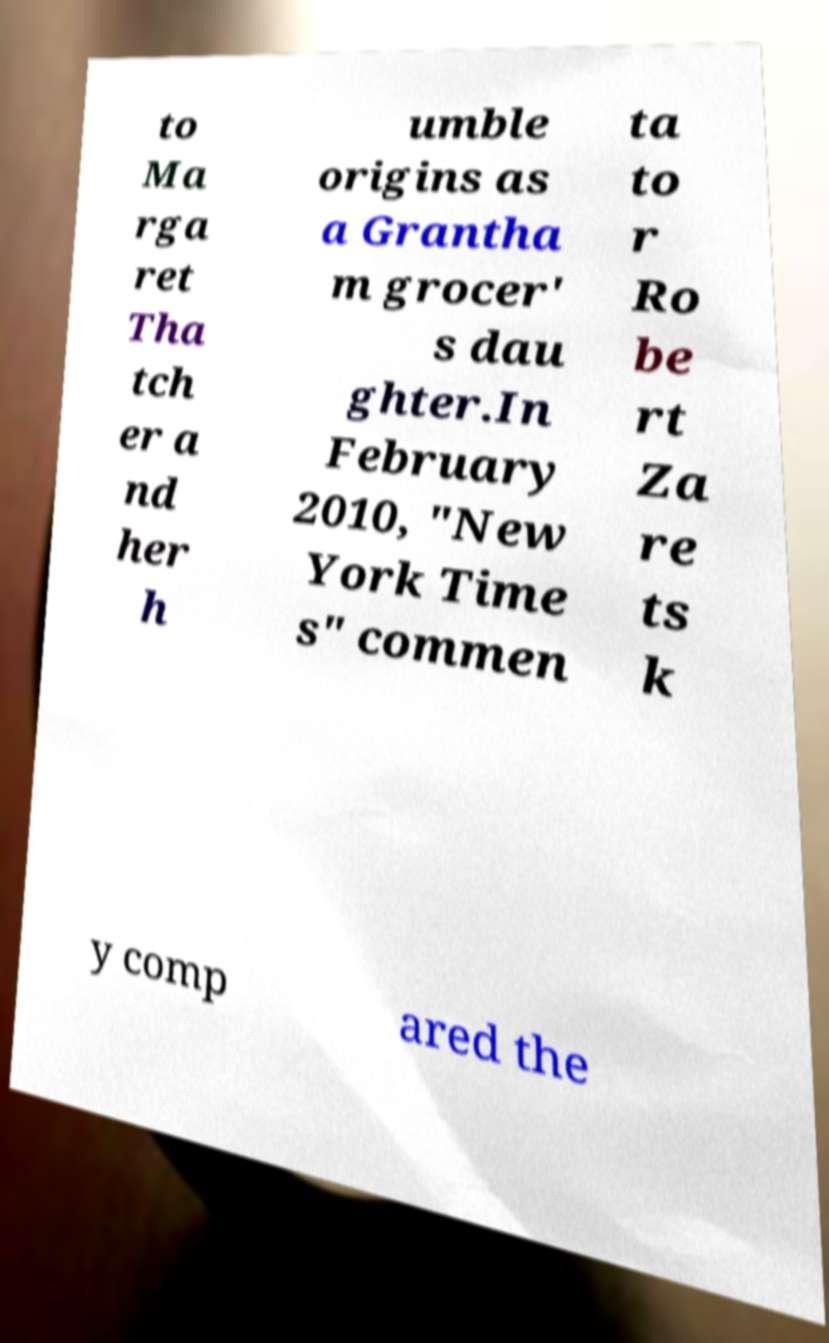Could you extract and type out the text from this image? to Ma rga ret Tha tch er a nd her h umble origins as a Grantha m grocer' s dau ghter.In February 2010, "New York Time s" commen ta to r Ro be rt Za re ts k y comp ared the 